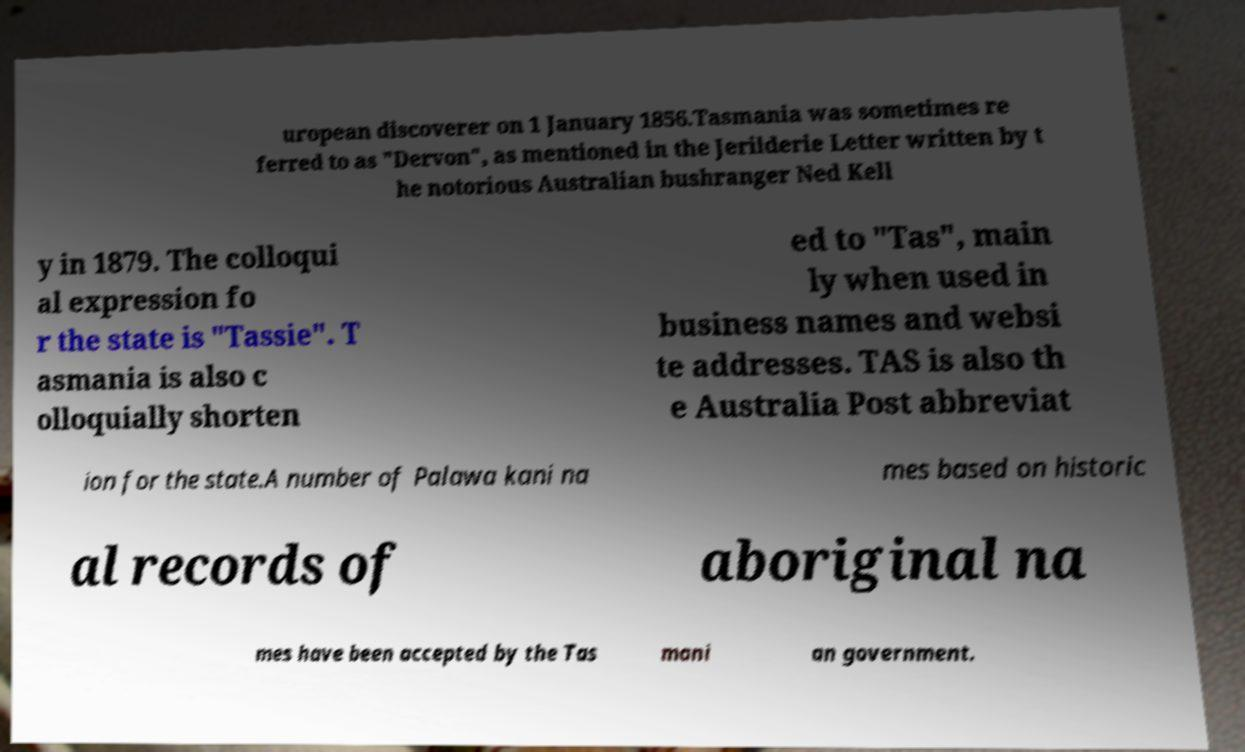Please identify and transcribe the text found in this image. uropean discoverer on 1 January 1856.Tasmania was sometimes re ferred to as "Dervon", as mentioned in the Jerilderie Letter written by t he notorious Australian bushranger Ned Kell y in 1879. The colloqui al expression fo r the state is "Tassie". T asmania is also c olloquially shorten ed to "Tas", main ly when used in business names and websi te addresses. TAS is also th e Australia Post abbreviat ion for the state.A number of Palawa kani na mes based on historic al records of aboriginal na mes have been accepted by the Tas mani an government. 